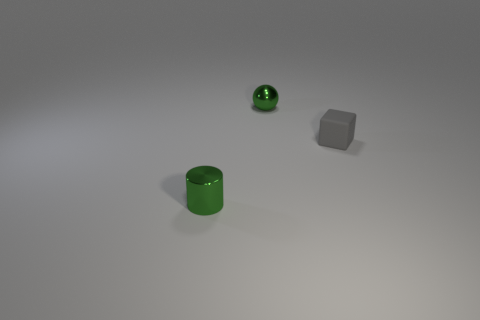What is the material of the small thing that is the same color as the tiny sphere?
Your answer should be compact. Metal. There is a small metallic object behind the small green shiny cylinder; does it have the same color as the thing that is on the right side of the tiny green sphere?
Your response must be concise. No. There is a tiny rubber block; are there any green shiny things behind it?
Ensure brevity in your answer.  Yes. What is the tiny cylinder made of?
Keep it short and to the point. Metal. What shape is the small thing that is right of the small ball?
Provide a succinct answer. Cube. Are there any other metal cylinders that have the same size as the green cylinder?
Keep it short and to the point. No. Are the green thing that is on the right side of the metallic cylinder and the green cylinder made of the same material?
Make the answer very short. Yes. Are there an equal number of green objects in front of the small gray block and metallic cylinders behind the ball?
Your answer should be compact. No. The tiny object that is in front of the small green metal sphere and left of the gray rubber object has what shape?
Give a very brief answer. Cylinder. There is a small green metal cylinder; how many small objects are behind it?
Offer a very short reply. 2. 